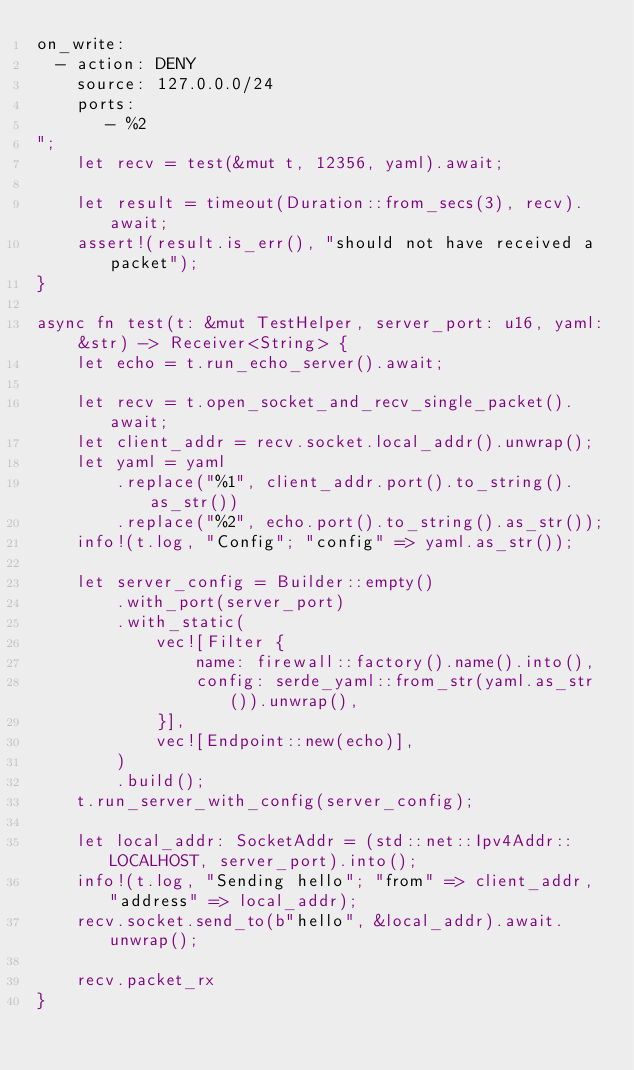<code> <loc_0><loc_0><loc_500><loc_500><_Rust_>on_write:
  - action: DENY
    source: 127.0.0.0/24
    ports:
       - %2
";
    let recv = test(&mut t, 12356, yaml).await;

    let result = timeout(Duration::from_secs(3), recv).await;
    assert!(result.is_err(), "should not have received a packet");
}

async fn test(t: &mut TestHelper, server_port: u16, yaml: &str) -> Receiver<String> {
    let echo = t.run_echo_server().await;

    let recv = t.open_socket_and_recv_single_packet().await;
    let client_addr = recv.socket.local_addr().unwrap();
    let yaml = yaml
        .replace("%1", client_addr.port().to_string().as_str())
        .replace("%2", echo.port().to_string().as_str());
    info!(t.log, "Config"; "config" => yaml.as_str());

    let server_config = Builder::empty()
        .with_port(server_port)
        .with_static(
            vec![Filter {
                name: firewall::factory().name().into(),
                config: serde_yaml::from_str(yaml.as_str()).unwrap(),
            }],
            vec![Endpoint::new(echo)],
        )
        .build();
    t.run_server_with_config(server_config);

    let local_addr: SocketAddr = (std::net::Ipv4Addr::LOCALHOST, server_port).into();
    info!(t.log, "Sending hello"; "from" => client_addr, "address" => local_addr);
    recv.socket.send_to(b"hello", &local_addr).await.unwrap();

    recv.packet_rx
}
</code> 